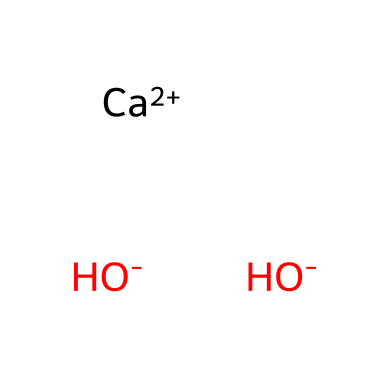What is the chemical name of the compound represented? The SMILES notation represents calcium hydroxide, which is a base formed from calcium ions and hydroxide ions. The presence of calcium (Ca) and hydroxide (OH) in the structure confirms this.
Answer: calcium hydroxide How many hydroxide ions are present in the structure? The SMILES notation lists two hydroxide groups (OH-), indicating that there are two hydrogen and oxygen atoms bonded as hydroxide ions.
Answer: two What type of chemical is calcium hydroxide classified as? Calcium hydroxide is classified as a base due to the presence of hydroxide ions, which can accept protons (H+) in reactions.
Answer: base What is the oxidation state of calcium in this compound? In calcium hydroxide, the calcium ion has a charge of +2 (indicated by [Ca++] in the SMILES), so its oxidation state is +2.
Answer: +2 How many total atoms are present in the structure? Analyzing the SMILES indicates there are three atoms of oxygen, two atoms of hydrogen, and one atom of calcium, totaling six atoms (1 Ca + 2 O + 2 H = 5).
Answer: five What is the role of calcium in the structure of calcium hydroxide? Calcium serves as the central cation, balancing the negative charges from the two hydroxide ions, contributing to the overall neutrality of the molecule.
Answer: central cation Is calcium hydroxide soluble in water? Calcium hydroxide has limited solubility in water but can dissociate to release hydroxide ions, resulting in a basic solution.
Answer: limited solubility 